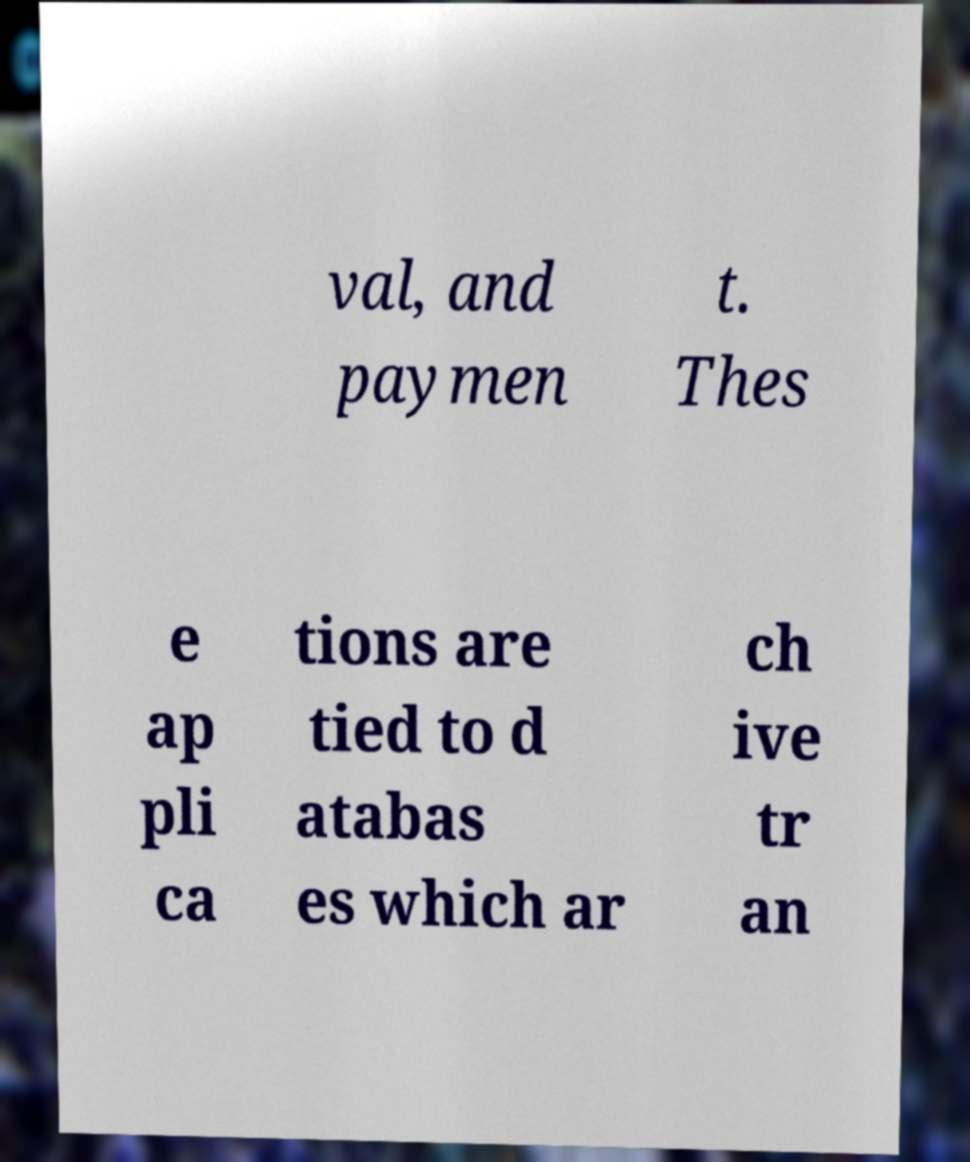Can you accurately transcribe the text from the provided image for me? val, and paymen t. Thes e ap pli ca tions are tied to d atabas es which ar ch ive tr an 